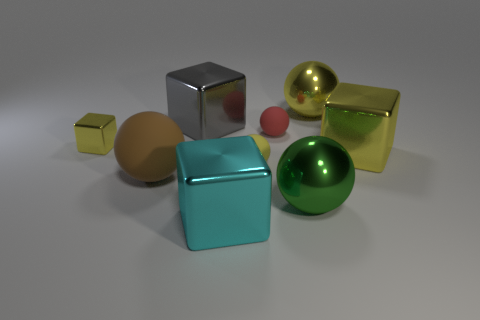Can you describe the texture and material of the large turquoise cube? The large turquoise cube in the image has a smooth, slightly reflective surface that suggests it might be made of a polished metal or a plastic material with a metallic finish. 